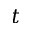Convert formula to latex. <formula><loc_0><loc_0><loc_500><loc_500>t</formula> 